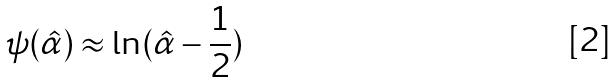Convert formula to latex. <formula><loc_0><loc_0><loc_500><loc_500>\psi ( \hat { \alpha } ) \approx \ln ( \hat { \alpha } - \frac { 1 } { 2 } )</formula> 